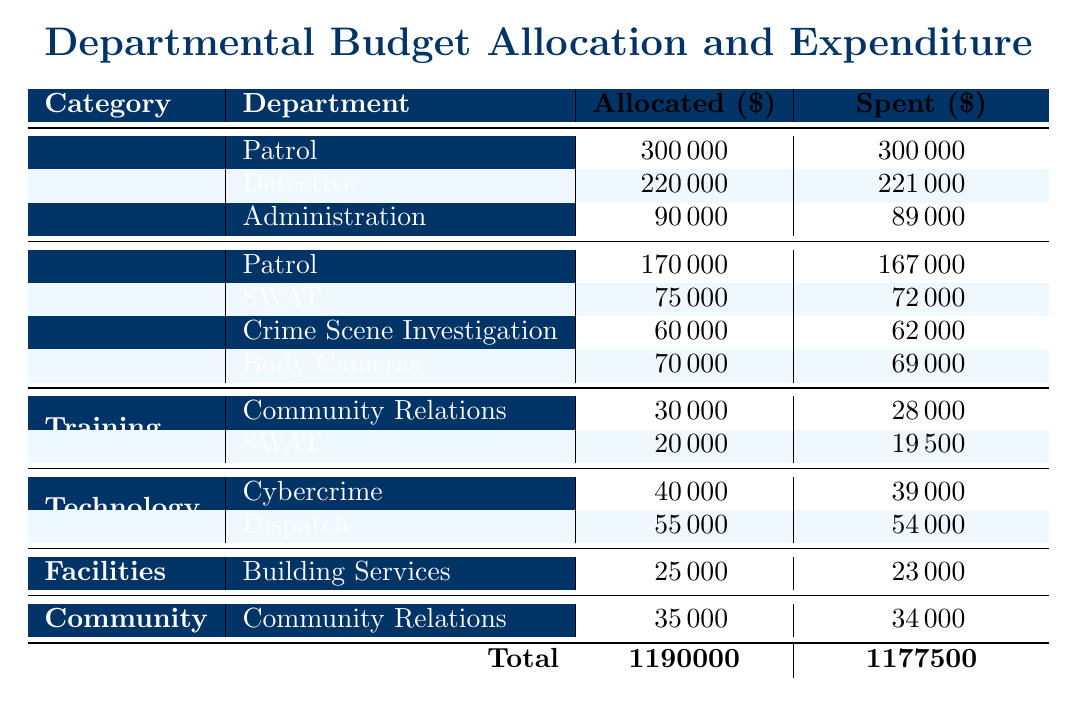What is the total allocated budget for the Personnel category? To find the total allocated budget for the Personnel category, we need to sum the allocated amounts for each department under Personnel: Patrol (300000) + Detective (220000) + Administration (90000) = 610000.
Answer: 610000 How much was spent on Equipment across all departments? To find the total spent on Equipment, we sum the spent amounts for each department under Equipment: Patrol (167000) + SWAT (72000) + Crime Scene Investigation (62000) + Body Cameras (69000) = 286000.
Answer: 286000 Which department had the highest spent amount in the Training category? In the Training category, the departments spent as follows: Community Relations (28000) and SWAT (19500). The highest spent amount is 28000 by Community Relations.
Answer: Community Relations Is the total expenditure less than the total allocation for the entire budget? The total allocated amount is 1190000 and the total spent amount is 1177500. Since 1177500 is less than 1190000, the statement is true.
Answer: Yes What is the average allocated budget for the Technology category? The allocated amounts for the Technology category are Cybercrime (40000) and Dispatch (55000). To find the average, we sum them: 40000 + 55000 = 95000, and then divide by 2: 95000/2 = 47500.
Answer: 47500 What is the difference between the total spent and allocated amounts for the Personnel category? The total allocated for Personnel is 610000, while the total spent is 610000. The difference is 610000 - 610000 = 0, meaning the spending matches the allocation.
Answer: 0 Which subcategory under Equipment had the highest allocation? The subcategories under Equipment with their allocations are Patrol (170000), SWAT (75000), Crime Scene Investigation (60000), and Body Cameras (70000). The highest allocation is 170000 for Patrol.
Answer: Patrol How much was allocated for the Community category? The only entry under the Community category is Community Relations, which had an allocated amount of 35000.
Answer: 35000 What is the total allocated budget for all categories combined? To find the total allocated budget, we add all the allocated amounts: 300000 (Personnel, Patrol) + 220000 (Personnel, Detective) + 90000 (Personnel, Administration) + 170000 (Equipment, Patrol) + 75000 (Equipment, SWAT) + 60000 (Equipment, Crime Scene Investigation) + 70000 (Equipment, Body Cameras) + 30000 (Training, Community Relations) + 20000 (Training, SWAT) + 40000 (Technology, Cybercrime) + 55000 (Technology, Dispatch) + 25000 (Facilities, Building Services) + 35000 (Community, Community Relations) = 1190000.
Answer: 1190000 